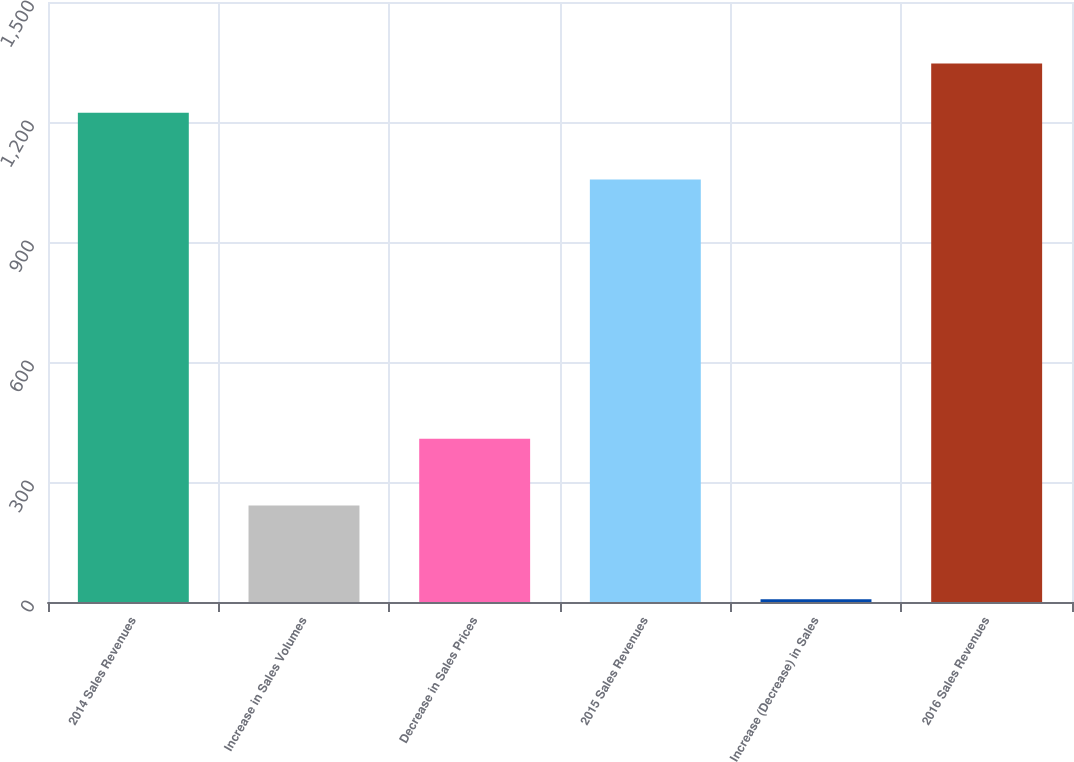Convert chart. <chart><loc_0><loc_0><loc_500><loc_500><bar_chart><fcel>2014 Sales Revenues<fcel>Increase in Sales Volumes<fcel>Decrease in Sales Prices<fcel>2015 Sales Revenues<fcel>Increase (Decrease) in Sales<fcel>2016 Sales Revenues<nl><fcel>1223<fcel>241<fcel>408<fcel>1056<fcel>7<fcel>1346.2<nl></chart> 